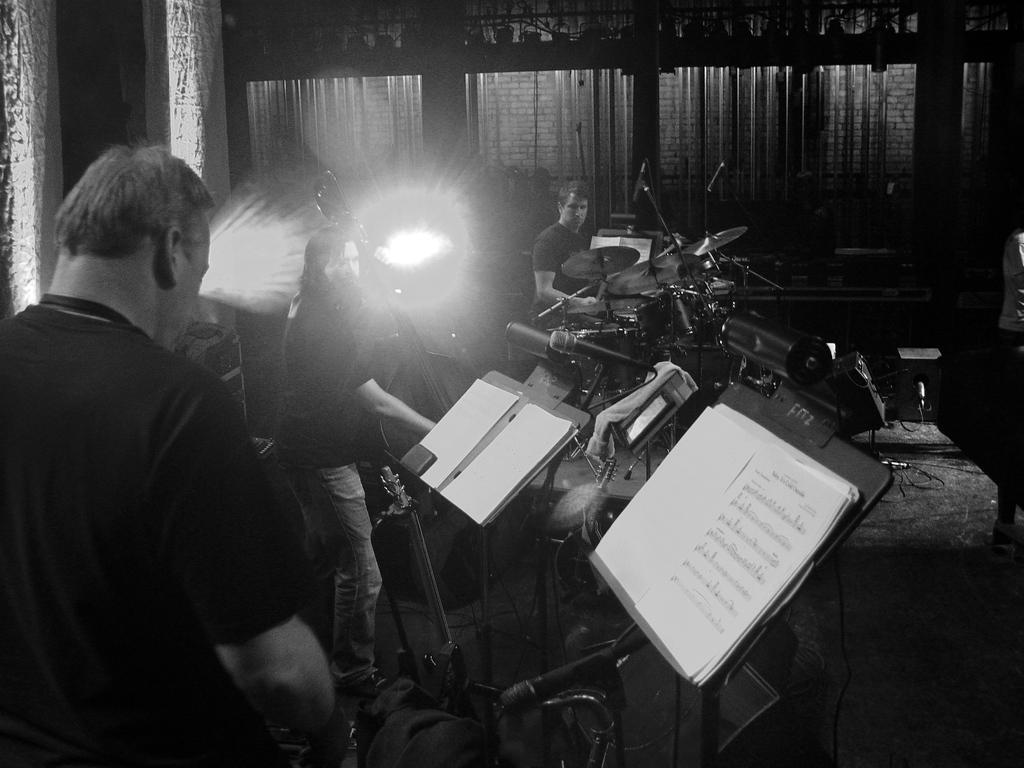How many people are performing on stage in the image? There are three men in the image. What are the men doing on stage? The men are playing music on a stage. Which instrument is one of the men playing? One man is playing drums. Which instrument is another man playing? Another man is playing cello. How much profit did the lizards make from the performance in the image? There are no lizards present in the image, and therefore no profit can be attributed to them. 